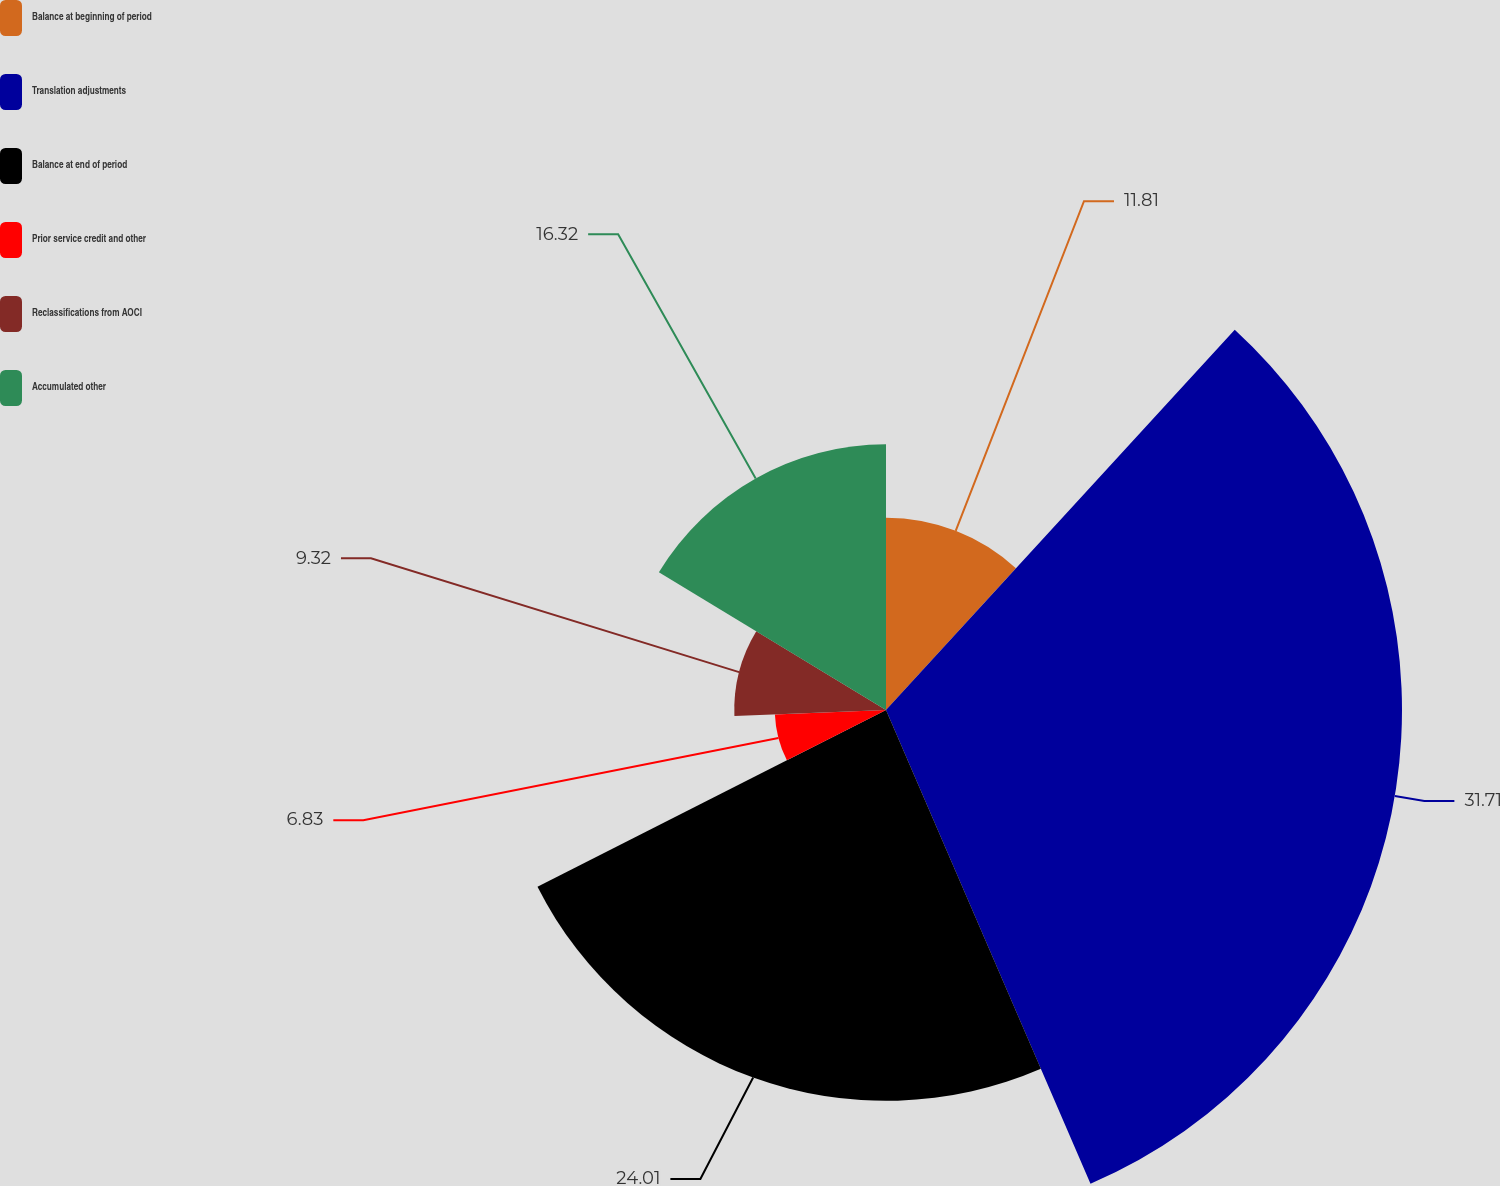<chart> <loc_0><loc_0><loc_500><loc_500><pie_chart><fcel>Balance at beginning of period<fcel>Translation adjustments<fcel>Balance at end of period<fcel>Prior service credit and other<fcel>Reclassifications from AOCI<fcel>Accumulated other<nl><fcel>11.81%<fcel>31.7%<fcel>24.01%<fcel>6.83%<fcel>9.32%<fcel>16.32%<nl></chart> 